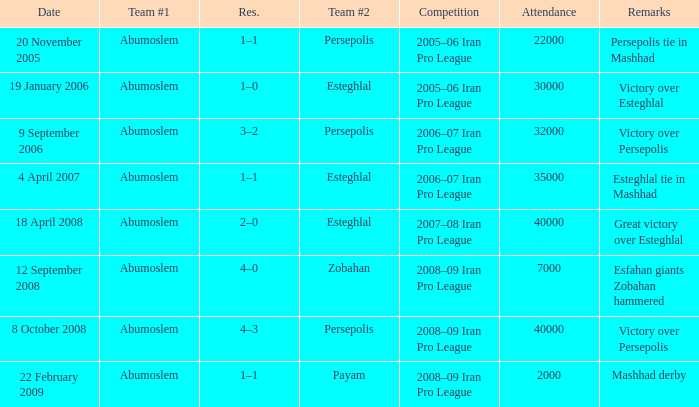Who was the leading team on 9th september 2006? Abumoslem. 